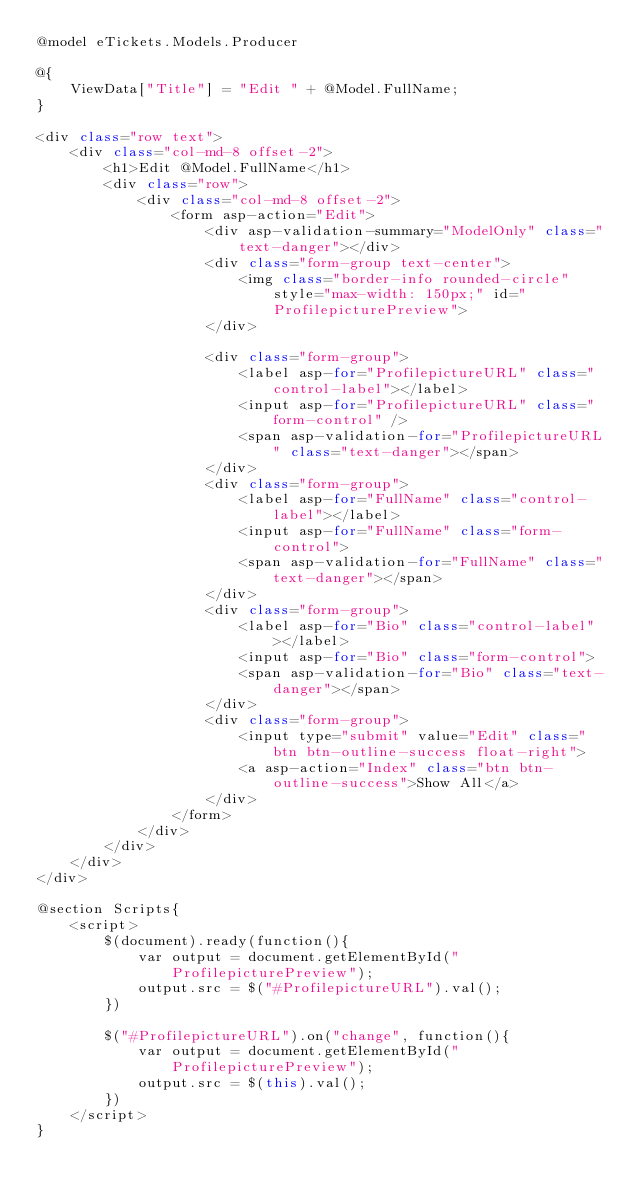Convert code to text. <code><loc_0><loc_0><loc_500><loc_500><_C#_>@model eTickets.Models.Producer

@{
    ViewData["Title"] = "Edit " + @Model.FullName;
}

<div class="row text">
    <div class="col-md-8 offset-2">
        <h1>Edit @Model.FullName</h1>
        <div class="row">
            <div class="col-md-8 offset-2">
                <form asp-action="Edit">
                    <div asp-validation-summary="ModelOnly" class="text-danger"></div>
                    <div class="form-group text-center">
                        <img class="border-info rounded-circle" style="max-width: 150px;" id="ProfilepicturePreview">
                    </div>

                    <div class="form-group">
                        <label asp-for="ProfilepictureURL" class="control-label"></label>
                        <input asp-for="ProfilepictureURL" class="form-control" />
                        <span asp-validation-for="ProfilepictureURL" class="text-danger"></span>
                    </div>
                    <div class="form-group">
                        <label asp-for="FullName" class="control-label"></label>
                        <input asp-for="FullName" class="form-control">
                        <span asp-validation-for="FullName" class="text-danger"></span>
                    </div>
                    <div class="form-group">
                        <label asp-for="Bio" class="control-label"></label>
                        <input asp-for="Bio" class="form-control">
                        <span asp-validation-for="Bio" class="text-danger"></span>
                    </div>
                    <div class="form-group">
                        <input type="submit" value="Edit" class="btn btn-outline-success float-right">
                        <a asp-action="Index" class="btn btn-outline-success">Show All</a>
                    </div>
                </form>
            </div>
        </div>
    </div>
</div>

@section Scripts{
    <script>
        $(document).ready(function(){
            var output = document.getElementById("ProfilepicturePreview");
            output.src = $("#ProfilepictureURL").val();
        })

        $("#ProfilepictureURL").on("change", function(){
            var output = document.getElementById("ProfilepicturePreview");
            output.src = $(this).val();
        })
    </script>
}</code> 